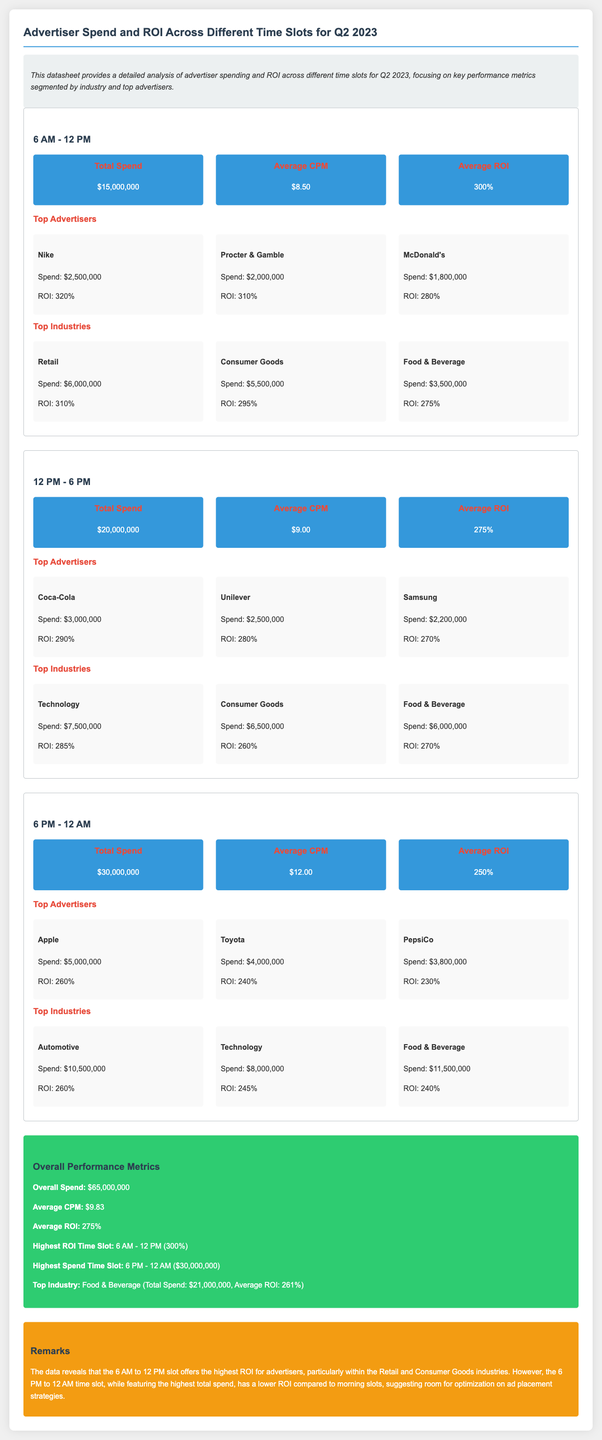what is the total spend for 6 AM - 12 PM? The total spend for the 6 AM - 12 PM time slot is stated in the document as $15,000,000.
Answer: $15,000,000 who is the top advertiser in the 12 PM - 6 PM slot? The document lists Coca-Cola as the top advertiser in the 12 PM - 6 PM time slot with a spend of $3,000,000.
Answer: Coca-Cola what is the average ROI for the 6 PM - 12 AM time slot? The average ROI for the 6 PM - 12 AM time slot is provided as 250%.
Answer: 250% which time slot has the highest total spend? The time slot with the highest total spend is mentioned as 6 PM - 12 AM, amounting to $30,000,000.
Answer: 6 PM - 12 AM what is the average CPM across all time slots? The document states the average CPM across all time slots as $9.83.
Answer: $9.83 how much did the Food & Beverage industry spend in total? The total spend for the Food & Beverage industry is calculated by adding the amounts across the time slots, which is $3,500,000 + $6,000,000 + $11,500,000 = $21,000,000.
Answer: $21,000,000 what is the highest ROI time slot? The highest ROI time slot is specified as 6 AM - 12 PM with an ROI of 300%.
Answer: 6 AM - 12 PM which industry spent the most overall? The top industry in terms of spend is revealed as Food & Beverage, with a total of $21,000,000.
Answer: Food & Beverage what are the remarks related to ad placement strategies? The remarks emphasize that there is room for optimization on ad placement strategies, particularly in the evening time slot.
Answer: room for optimization 